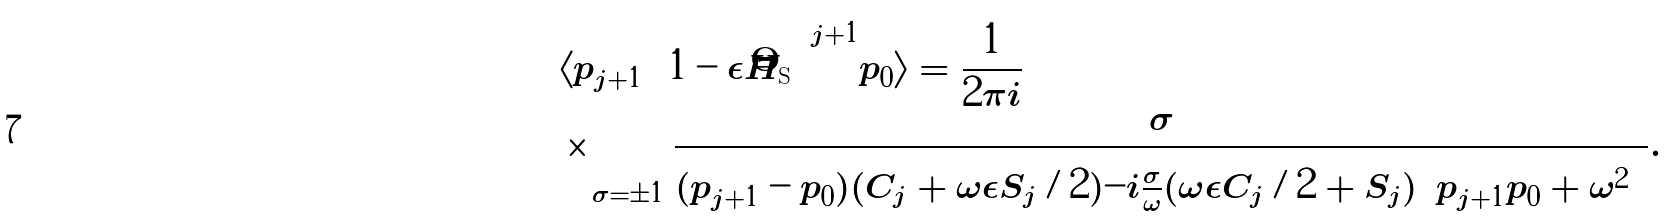Convert formula to latex. <formula><loc_0><loc_0><loc_500><loc_500>& \langle { p _ { j + 1 } } | \left ( 1 - \epsilon \hat { H } _ { \text {S} } \right ) ^ { j + 1 } | { p _ { 0 } } \rangle = \frac { 1 } { 2 \pi i } \\ & \times \sum _ { \sigma = \pm 1 } \frac { \sigma } { ( p _ { j + 1 } - p _ { 0 } ) ( C _ { j } + \omega \epsilon S _ { j } / 2 ) - i \frac { \sigma } { \omega } ( \omega \epsilon C _ { j } / 2 + S _ { j } ) \left ( p _ { j + 1 } p _ { 0 } + \omega ^ { 2 } \right ) } .</formula> 